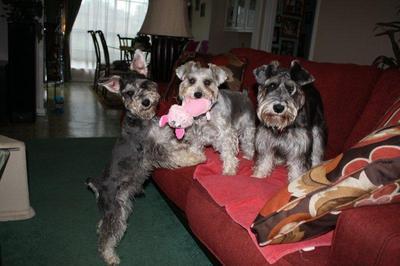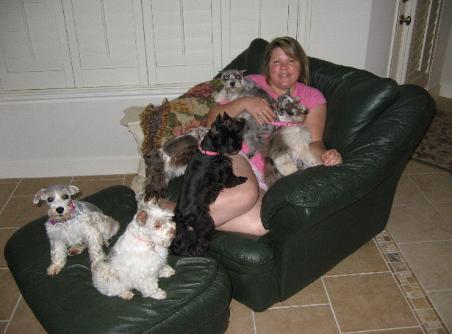The first image is the image on the left, the second image is the image on the right. Analyze the images presented: Is the assertion "There are exactly four dogs." valid? Answer yes or no. No. The first image is the image on the left, the second image is the image on the right. Considering the images on both sides, is "there is three dogs in the right side image" valid? Answer yes or no. No. 